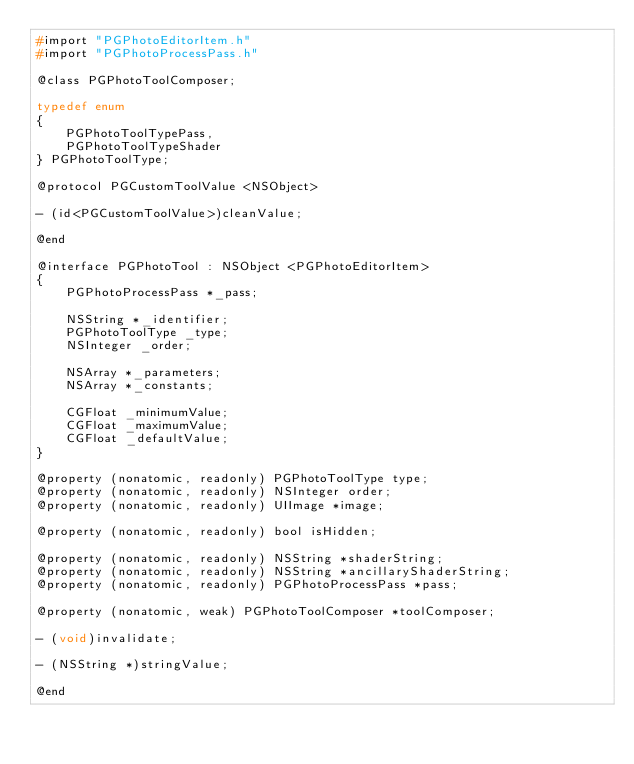<code> <loc_0><loc_0><loc_500><loc_500><_C_>#import "PGPhotoEditorItem.h"
#import "PGPhotoProcessPass.h"

@class PGPhotoToolComposer;

typedef enum
{
    PGPhotoToolTypePass,
    PGPhotoToolTypeShader
} PGPhotoToolType;

@protocol PGCustomToolValue <NSObject>

- (id<PGCustomToolValue>)cleanValue;

@end

@interface PGPhotoTool : NSObject <PGPhotoEditorItem>
{
    PGPhotoProcessPass *_pass;
    
    NSString *_identifier;
    PGPhotoToolType _type;
    NSInteger _order;
    
    NSArray *_parameters;
    NSArray *_constants;
    
    CGFloat _minimumValue;
    CGFloat _maximumValue;
    CGFloat _defaultValue;
}

@property (nonatomic, readonly) PGPhotoToolType type;
@property (nonatomic, readonly) NSInteger order;
@property (nonatomic, readonly) UIImage *image;

@property (nonatomic, readonly) bool isHidden;

@property (nonatomic, readonly) NSString *shaderString;
@property (nonatomic, readonly) NSString *ancillaryShaderString;
@property (nonatomic, readonly) PGPhotoProcessPass *pass;

@property (nonatomic, weak) PGPhotoToolComposer *toolComposer;

- (void)invalidate;

- (NSString *)stringValue;

@end
</code> 